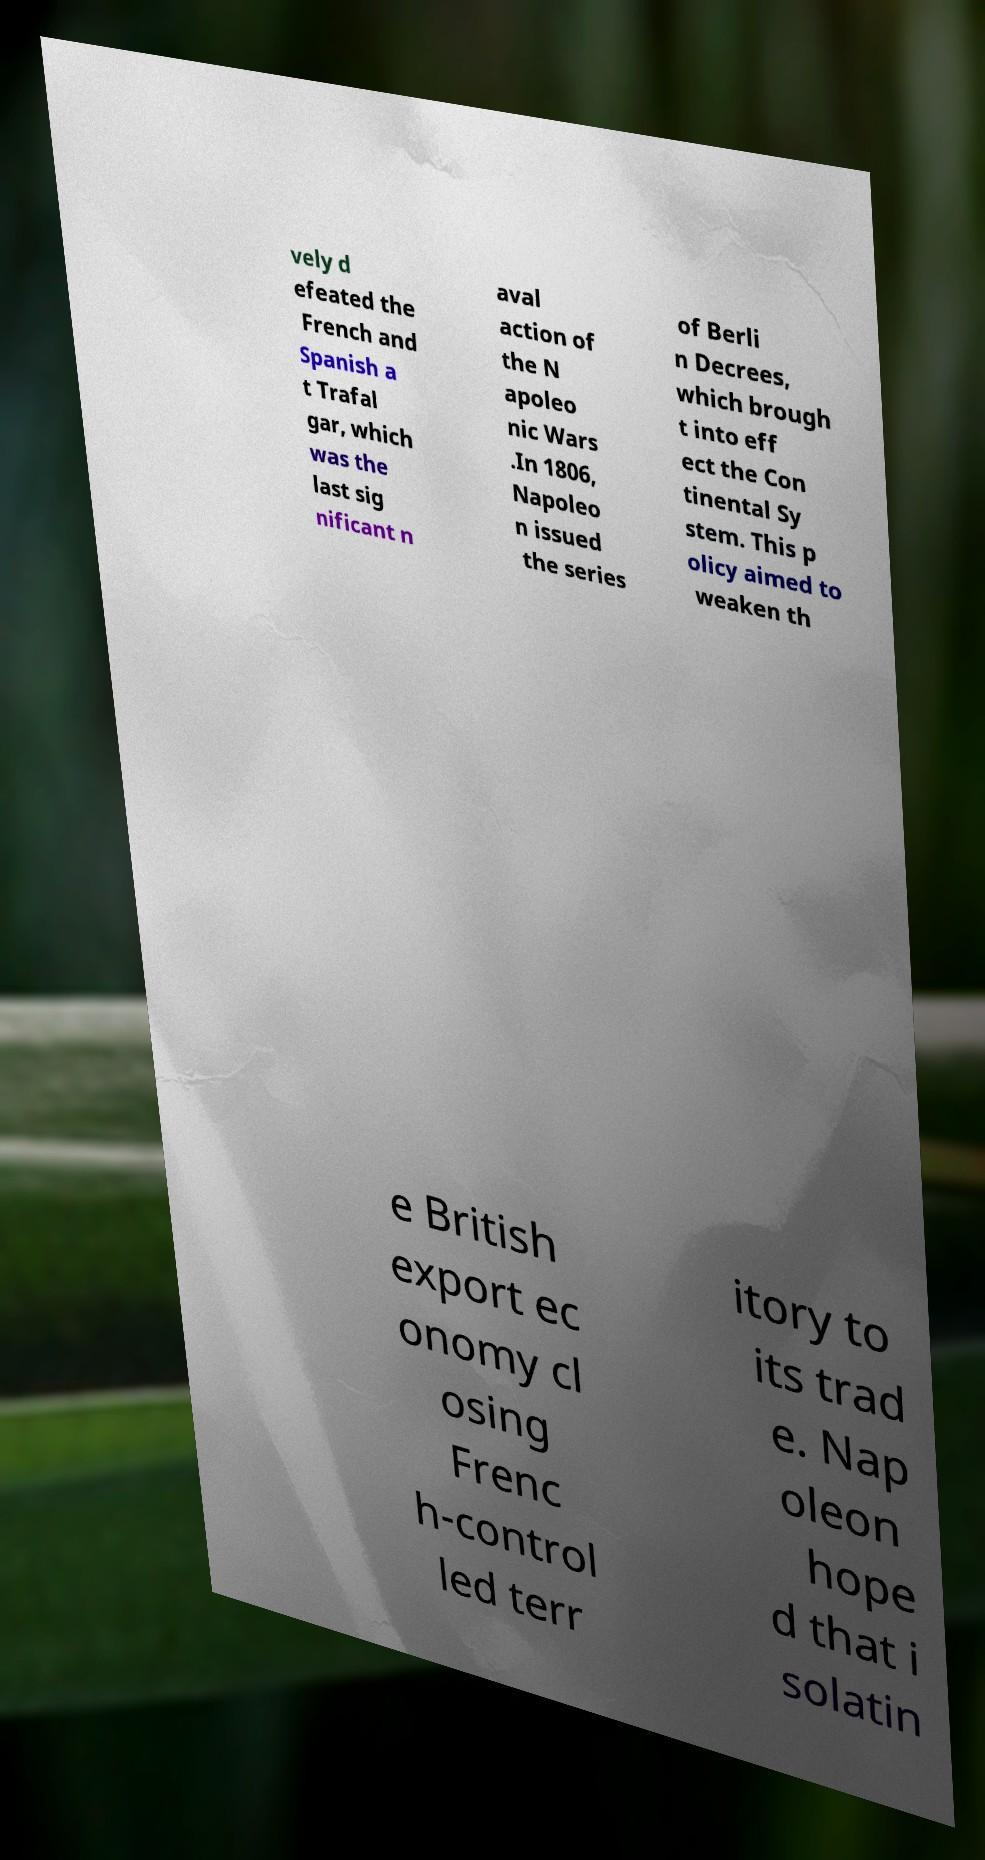There's text embedded in this image that I need extracted. Can you transcribe it verbatim? vely d efeated the French and Spanish a t Trafal gar, which was the last sig nificant n aval action of the N apoleo nic Wars .In 1806, Napoleo n issued the series of Berli n Decrees, which brough t into eff ect the Con tinental Sy stem. This p olicy aimed to weaken th e British export ec onomy cl osing Frenc h-control led terr itory to its trad e. Nap oleon hope d that i solatin 